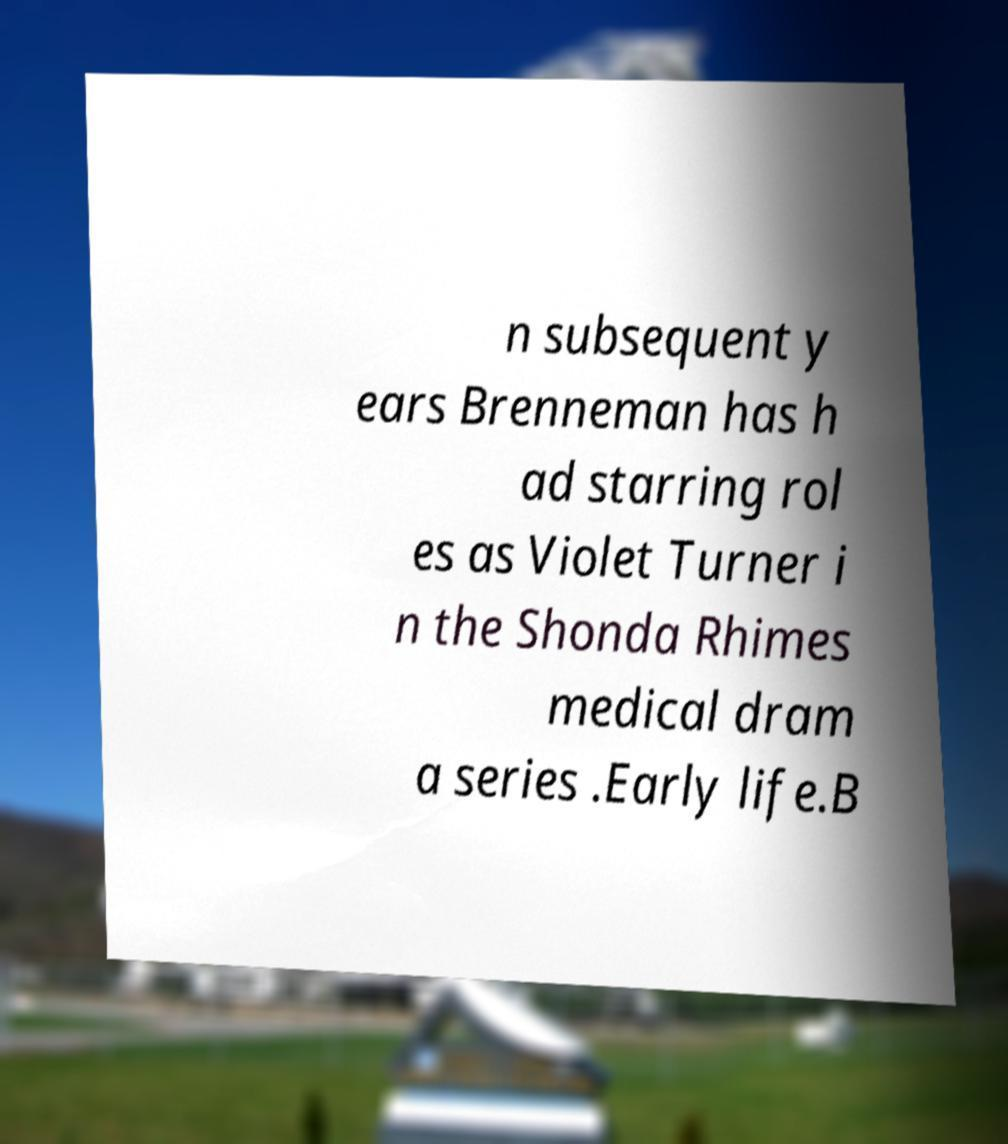What messages or text are displayed in this image? I need them in a readable, typed format. n subsequent y ears Brenneman has h ad starring rol es as Violet Turner i n the Shonda Rhimes medical dram a series .Early life.B 